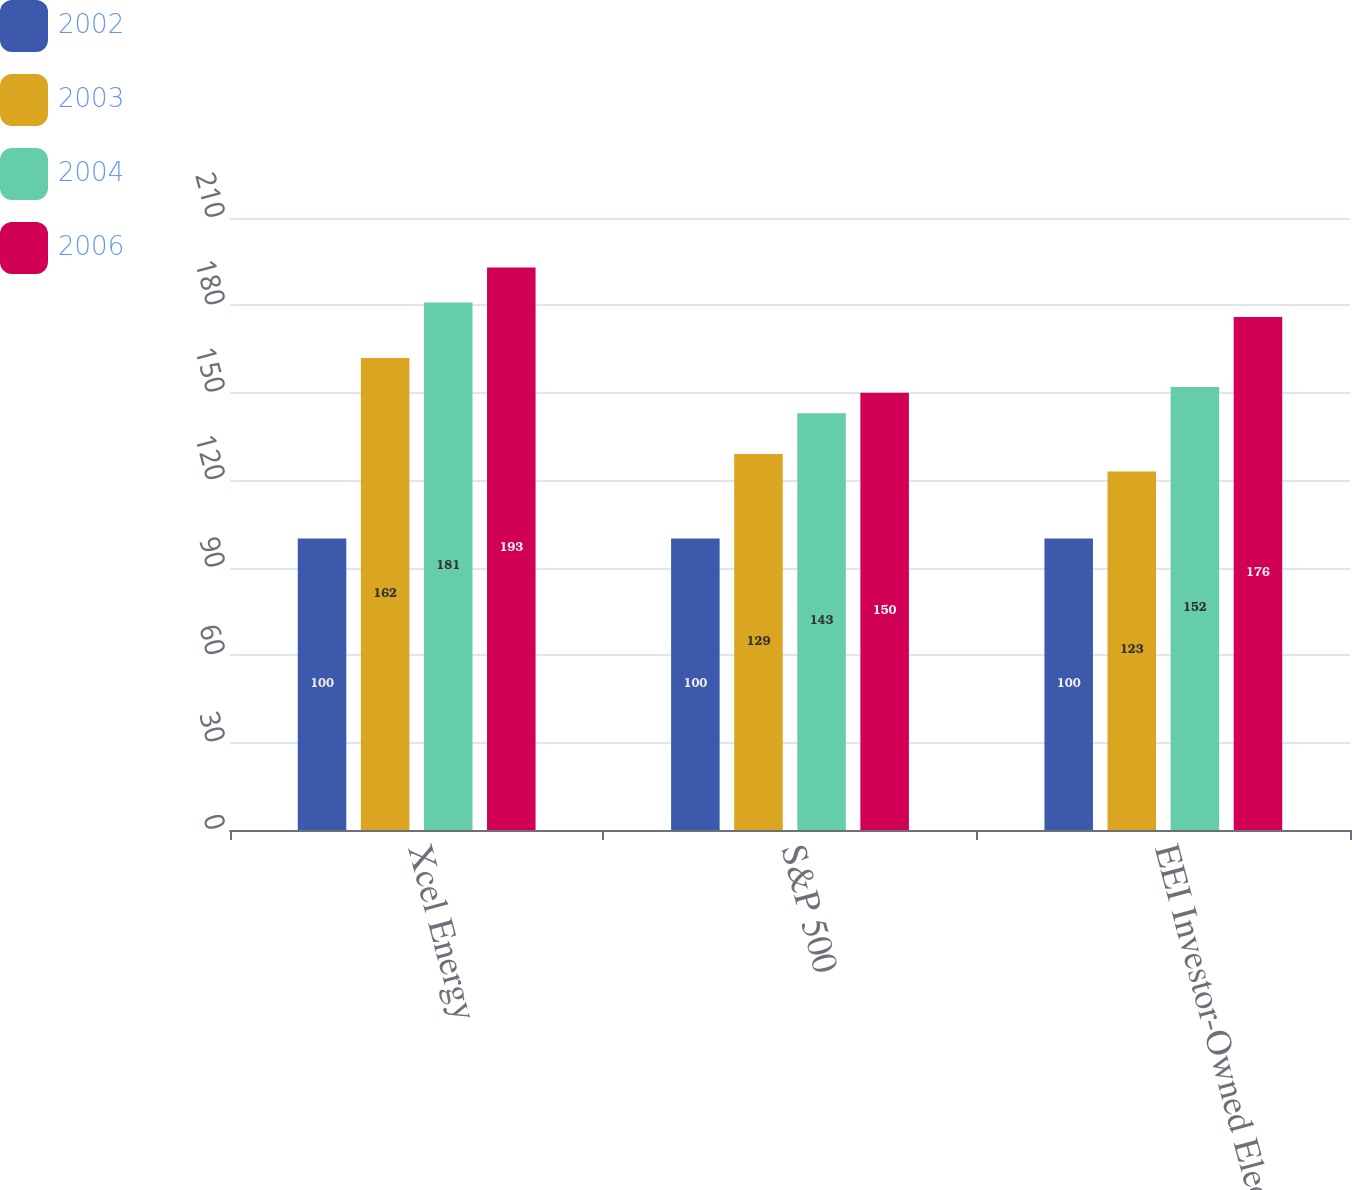<chart> <loc_0><loc_0><loc_500><loc_500><stacked_bar_chart><ecel><fcel>Xcel Energy<fcel>S&P 500<fcel>EEI Investor-Owned Electrics<nl><fcel>2002<fcel>100<fcel>100<fcel>100<nl><fcel>2003<fcel>162<fcel>129<fcel>123<nl><fcel>2004<fcel>181<fcel>143<fcel>152<nl><fcel>2006<fcel>193<fcel>150<fcel>176<nl></chart> 